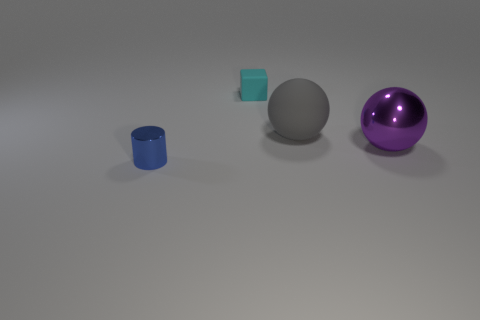Add 1 cylinders. How many objects exist? 5 Subtract all gray spheres. How many spheres are left? 1 Add 2 large objects. How many large objects are left? 4 Add 2 spheres. How many spheres exist? 4 Subtract 0 green cylinders. How many objects are left? 4 Subtract all cylinders. How many objects are left? 3 Subtract all brown spheres. Subtract all gray cylinders. How many spheres are left? 2 Subtract all small blue things. Subtract all tiny shiny things. How many objects are left? 2 